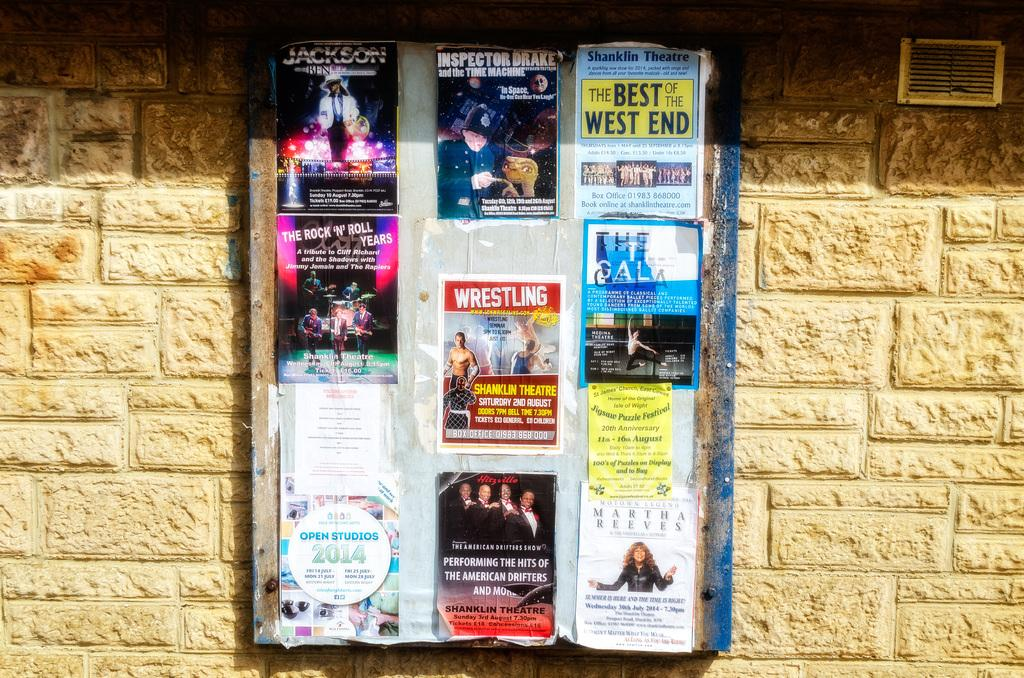<image>
Write a terse but informative summary of the picture. Many posters on a wall including one that says JACKSON. 